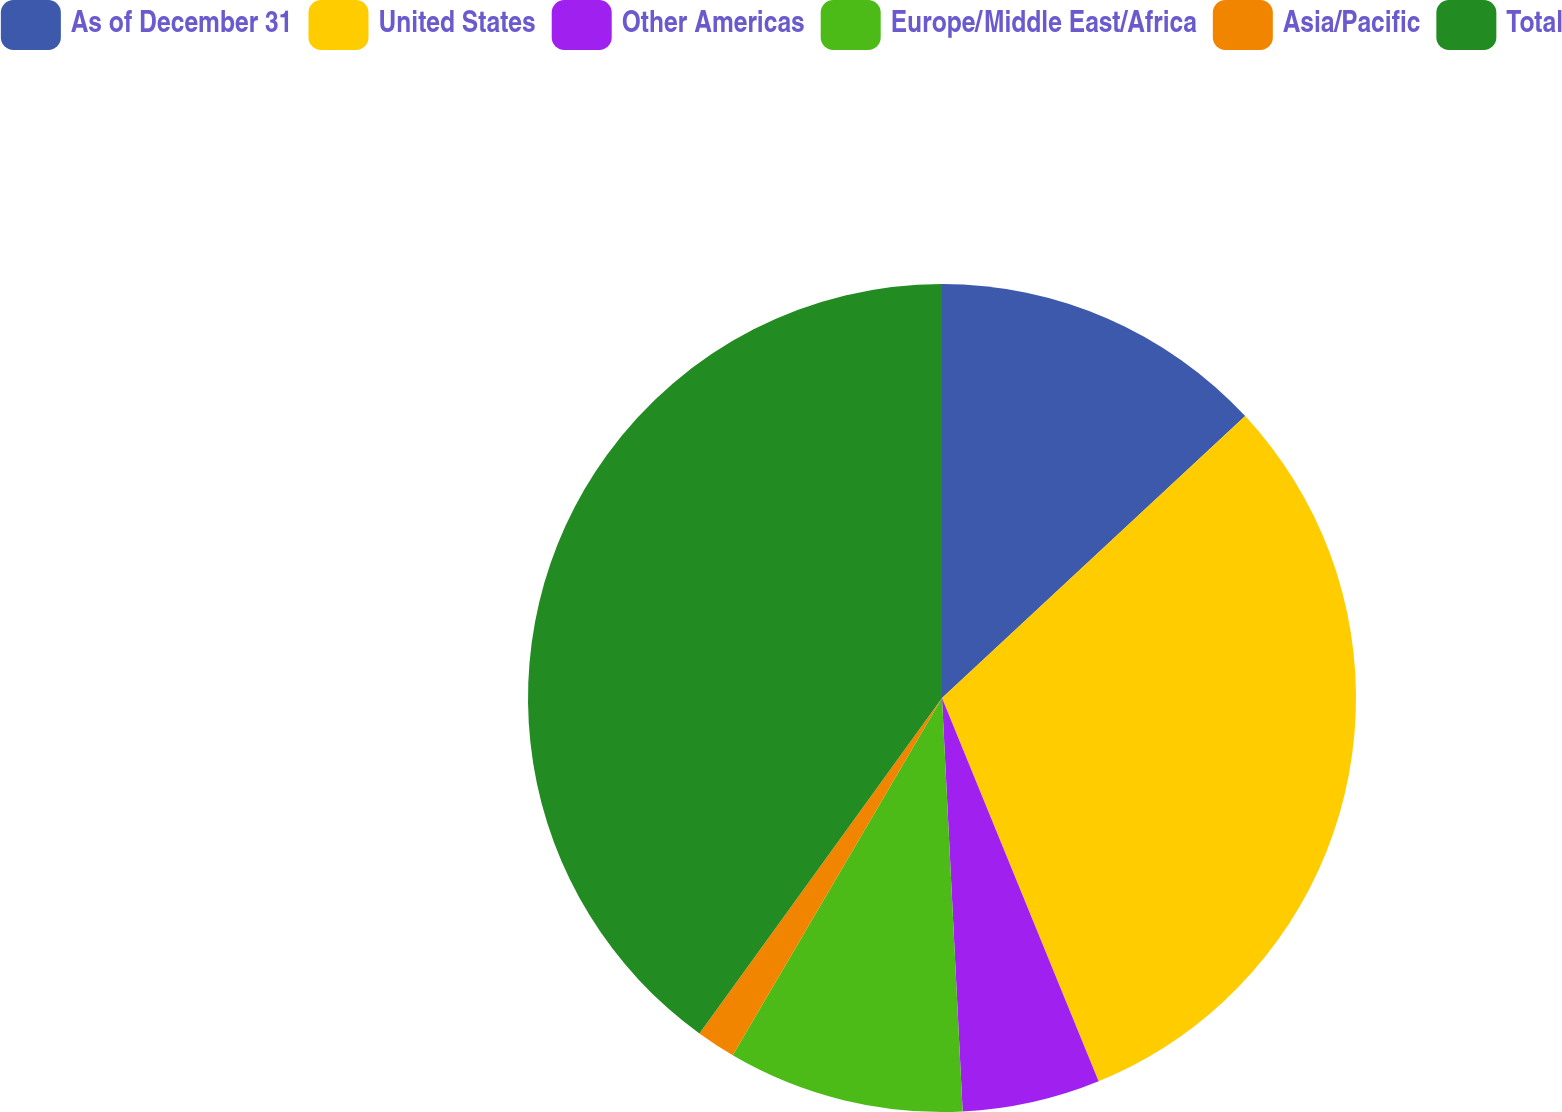<chart> <loc_0><loc_0><loc_500><loc_500><pie_chart><fcel>As of December 31<fcel>United States<fcel>Other Americas<fcel>Europe/Middle East/Africa<fcel>Asia/Pacific<fcel>Total<nl><fcel>13.08%<fcel>30.75%<fcel>5.38%<fcel>9.23%<fcel>1.53%<fcel>40.04%<nl></chart> 